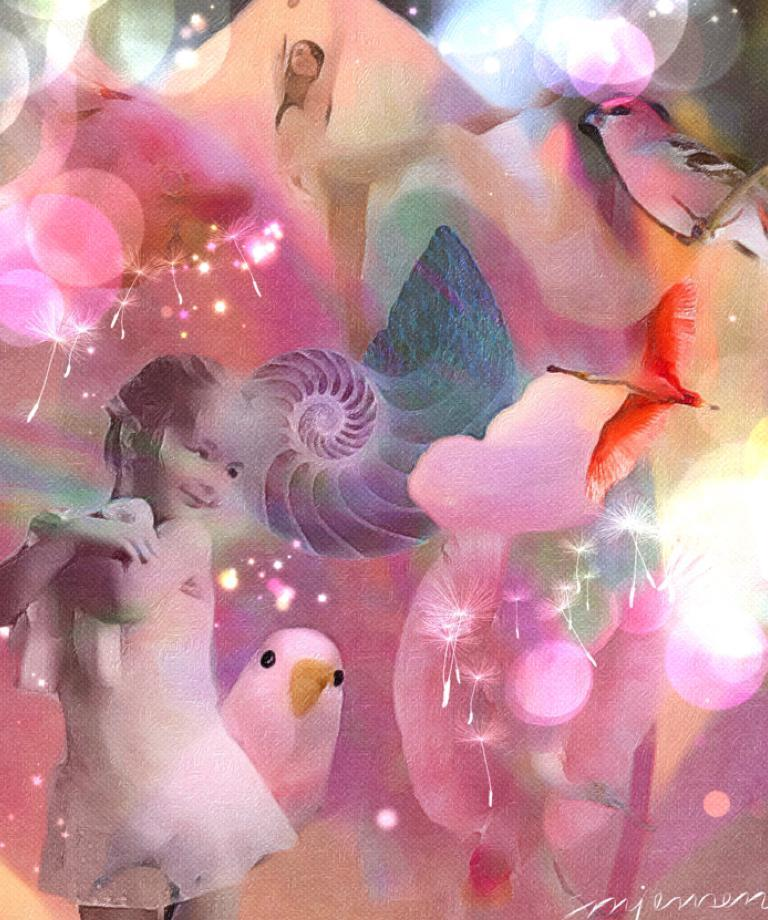What is the main subject in the image? There is a girl in the image (assuming the editing did not remove her). What other elements can be seen in the image? There are birds in the image (assuming the editing did not remove them) and light effects. What type of substance is the girl holding in the image? There is no substance visible in the image; the girl is not holding anything. What kind of shoes is the girl wearing in the image? The girl's shoes are not visible in the image, so it cannot be determined what type she is wearing. 